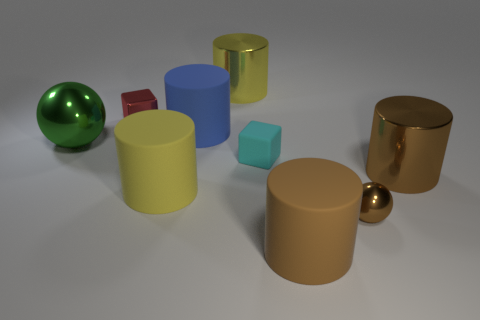Subtract all big blue cylinders. How many cylinders are left? 4 Subtract all blue cylinders. How many cylinders are left? 4 Subtract all red cylinders. Subtract all purple cubes. How many cylinders are left? 5 Add 1 tiny red metallic things. How many objects exist? 10 Subtract all blocks. How many objects are left? 7 Subtract all small cyan rubber things. Subtract all brown spheres. How many objects are left? 7 Add 5 big matte things. How many big matte things are left? 8 Add 3 large green objects. How many large green objects exist? 4 Subtract 0 blue spheres. How many objects are left? 9 